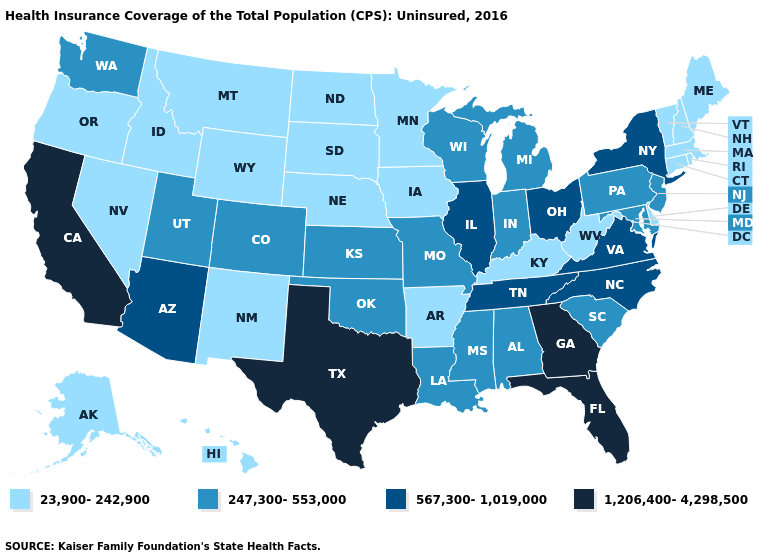Does Washington have the lowest value in the USA?
Be succinct. No. Name the states that have a value in the range 23,900-242,900?
Give a very brief answer. Alaska, Arkansas, Connecticut, Delaware, Hawaii, Idaho, Iowa, Kentucky, Maine, Massachusetts, Minnesota, Montana, Nebraska, Nevada, New Hampshire, New Mexico, North Dakota, Oregon, Rhode Island, South Dakota, Vermont, West Virginia, Wyoming. Does the map have missing data?
Keep it brief. No. Does Missouri have the highest value in the MidWest?
Answer briefly. No. What is the value of Montana?
Quick response, please. 23,900-242,900. Does Kansas have the same value as Rhode Island?
Answer briefly. No. Among the states that border Arkansas , does Texas have the highest value?
Keep it brief. Yes. What is the value of Nevada?
Concise answer only. 23,900-242,900. Does the map have missing data?
Quick response, please. No. Does Minnesota have the lowest value in the MidWest?
Be succinct. Yes. Does California have the highest value in the USA?
Write a very short answer. Yes. Which states have the lowest value in the MidWest?
Concise answer only. Iowa, Minnesota, Nebraska, North Dakota, South Dakota. What is the highest value in states that border Kansas?
Answer briefly. 247,300-553,000. Does Kentucky have the lowest value in the USA?
Give a very brief answer. Yes. Which states have the lowest value in the USA?
Keep it brief. Alaska, Arkansas, Connecticut, Delaware, Hawaii, Idaho, Iowa, Kentucky, Maine, Massachusetts, Minnesota, Montana, Nebraska, Nevada, New Hampshire, New Mexico, North Dakota, Oregon, Rhode Island, South Dakota, Vermont, West Virginia, Wyoming. 